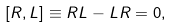Convert formula to latex. <formula><loc_0><loc_0><loc_500><loc_500>[ R , L ] \equiv R L - L R = 0 ,</formula> 